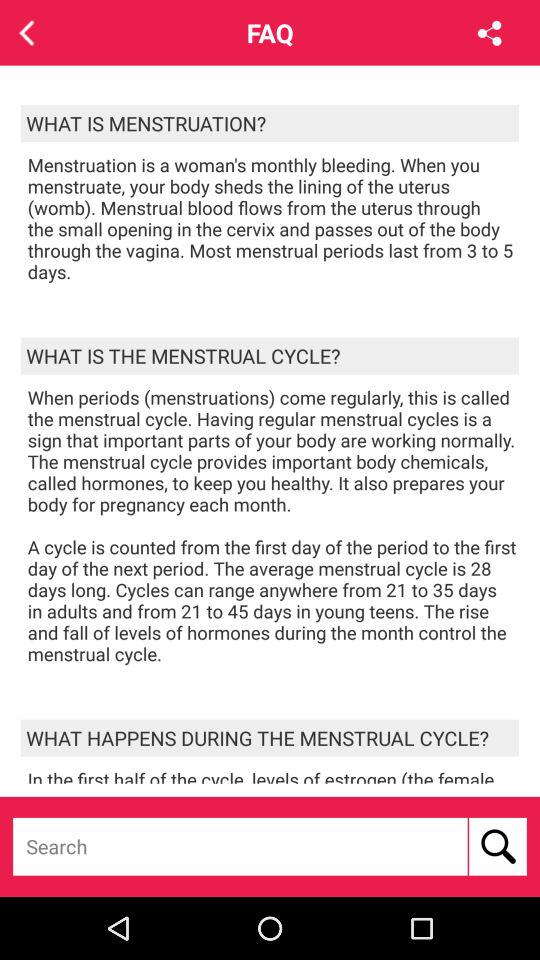What is the average menstrual cycle timing range for adults? The range is 21 to 35 days. 